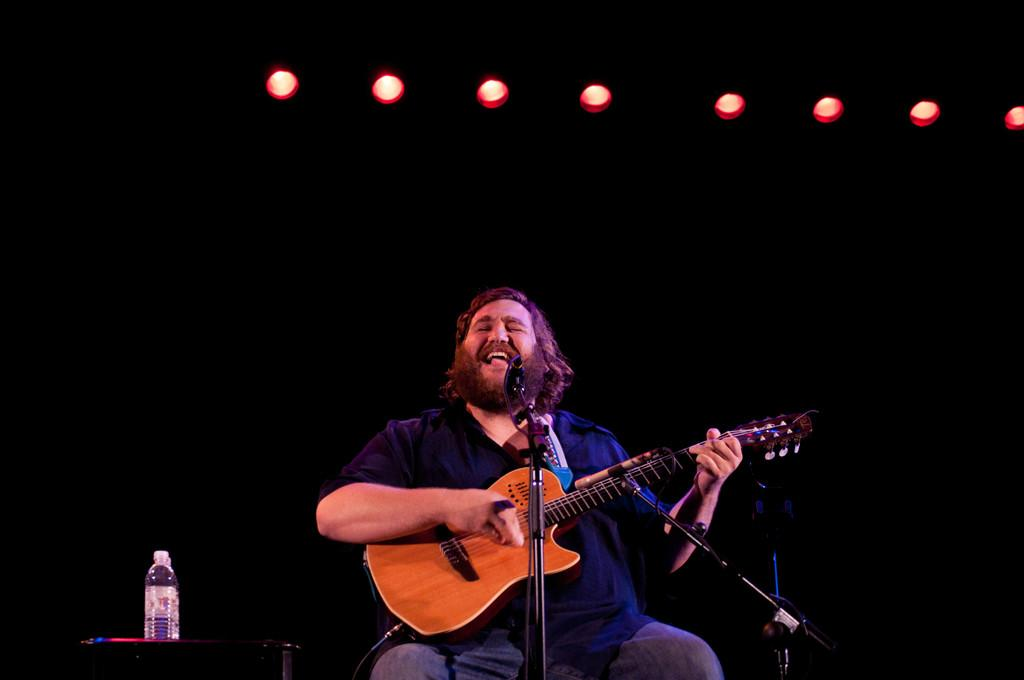What is the person in the image doing? The person is sitting in the image. What object is the person holding? The person is holding a guitar. What is the purpose of the microphone with a stand in the image? The microphone with a stand is likely used for amplifying the person's voice while playing the guitar. What can be seen on the table in the image? There are water bottles on a table in the image. What page: What page of the book is the person reading in the image? There is no book present in the image, so it is not possible to determine which page the person might be reading. 